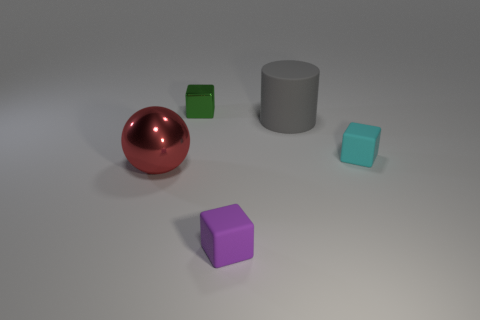Add 2 tiny green things. How many objects exist? 7 Subtract all spheres. How many objects are left? 4 Subtract 0 cyan balls. How many objects are left? 5 Subtract all large metal spheres. Subtract all tiny green cubes. How many objects are left? 3 Add 2 small cubes. How many small cubes are left? 5 Add 5 gray objects. How many gray objects exist? 6 